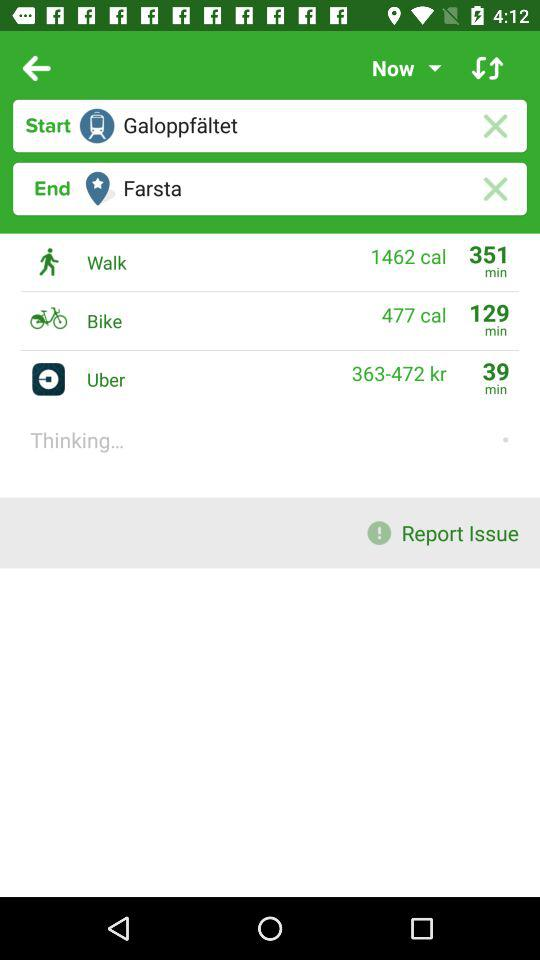What is the starting point? The starting point is "Galoppfaltet". 